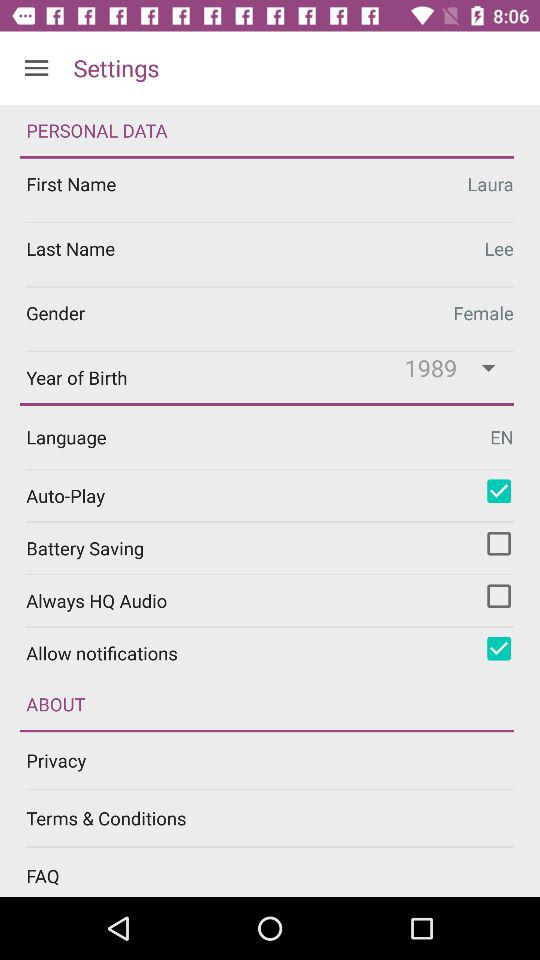What is the status of "Privacy"?
When the provided information is insufficient, respond with <no answer>. <no answer> 